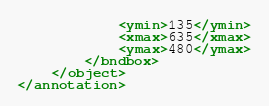Convert code to text. <code><loc_0><loc_0><loc_500><loc_500><_XML_>			<ymin>135</ymin>
			<xmax>635</xmax>
			<ymax>480</ymax>
		</bndbox>
	</object>
</annotation>
</code> 